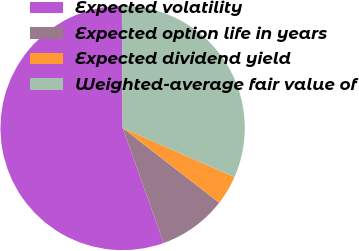<chart> <loc_0><loc_0><loc_500><loc_500><pie_chart><fcel>Expected volatility<fcel>Expected option life in years<fcel>Expected dividend yield<fcel>Weighted-average fair value of<nl><fcel>55.36%<fcel>9.05%<fcel>3.91%<fcel>31.68%<nl></chart> 